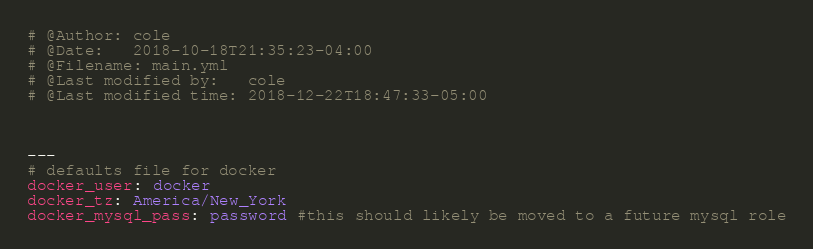Convert code to text. <code><loc_0><loc_0><loc_500><loc_500><_YAML_># @Author: cole
# @Date:   2018-10-18T21:35:23-04:00
# @Filename: main.yml
# @Last modified by:   cole
# @Last modified time: 2018-12-22T18:47:33-05:00



---
# defaults file for docker
docker_user: docker
docker_tz: America/New_York
docker_mysql_pass: password #this should likely be moved to a future mysql role
</code> 